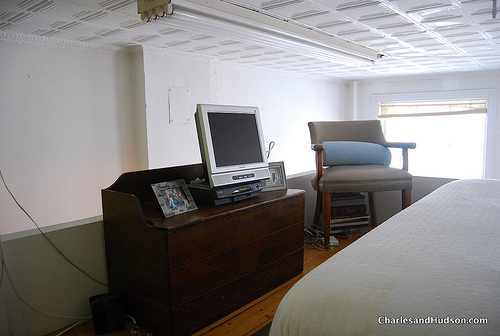What types of items are visible on the dresser besides the television? The dresser also has a silver frame, possibly containing a photograph, alongside some personal items or decorative elements. 